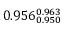<formula> <loc_0><loc_0><loc_500><loc_500>0 . 9 5 6 _ { 0 . 9 5 0 } ^ { 0 . 9 6 3 }</formula> 